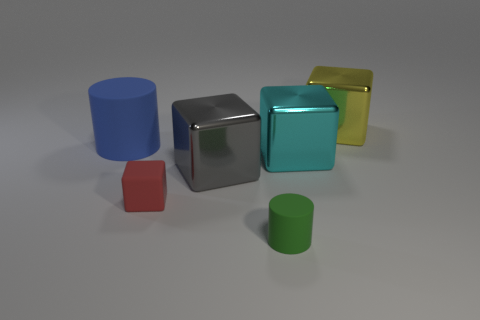Subtract all blue cubes. Subtract all gray spheres. How many cubes are left? 4 Add 4 green cylinders. How many objects exist? 10 Subtract all cylinders. How many objects are left? 4 Subtract 0 brown cylinders. How many objects are left? 6 Subtract all big blue objects. Subtract all red objects. How many objects are left? 4 Add 3 cylinders. How many cylinders are left? 5 Add 5 blue rubber cylinders. How many blue rubber cylinders exist? 6 